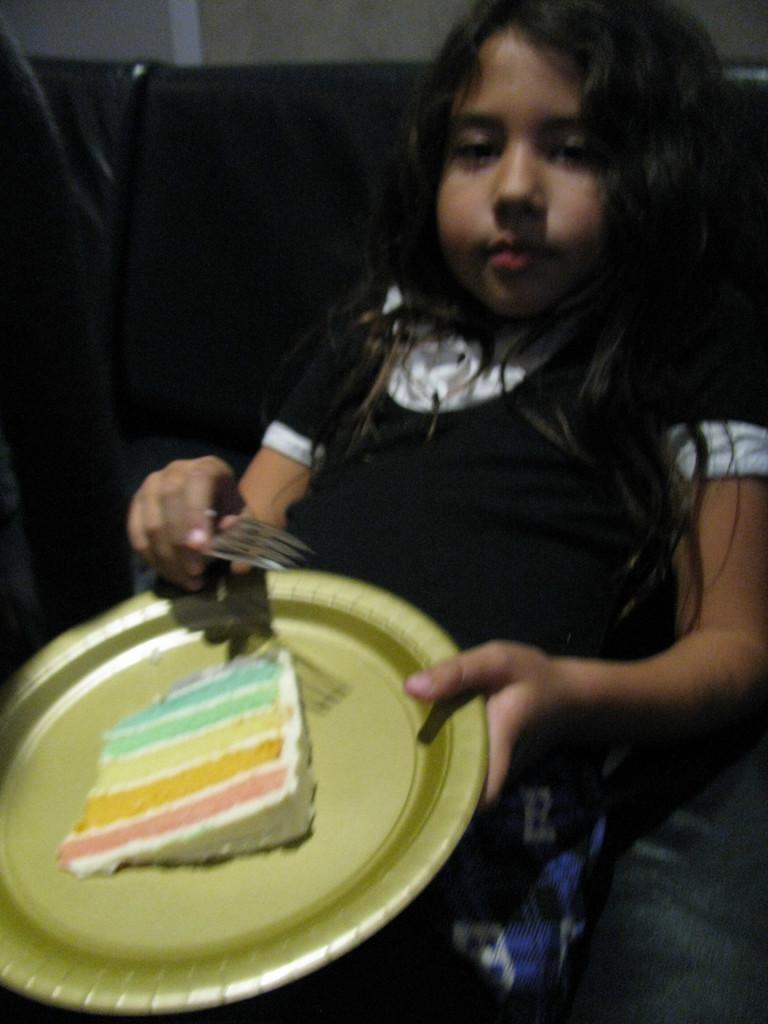In one or two sentences, can you explain what this image depicts? In this image I can see the person with the dress and holding the plate and fork. I can see the black background. I can see the food in the plate. 